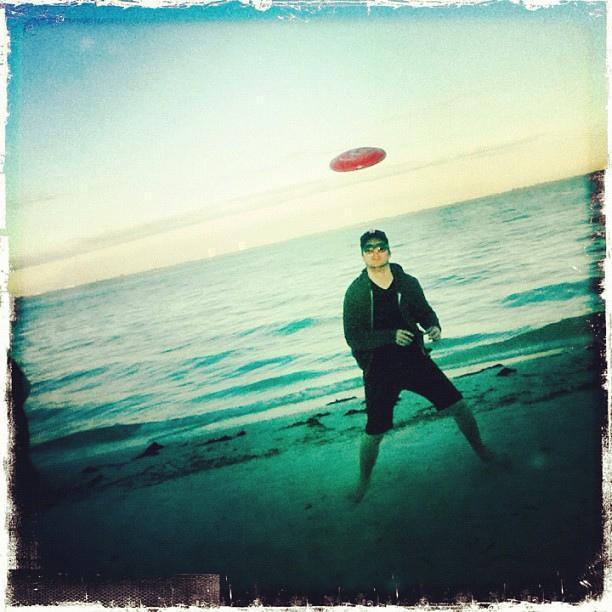How many people can you see?
Give a very brief answer. 1. 